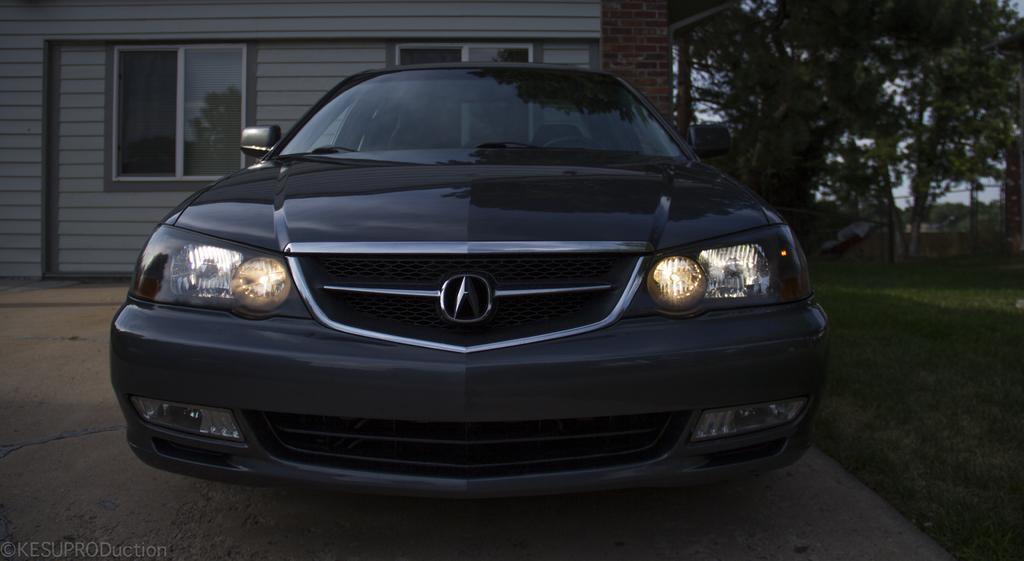Describe this image in one or two sentences. In this picture we can see car on the surface and grass. In the background of the image we can see wall, windows, trees and sky. In the bottom left side of the image we can see watermark. 